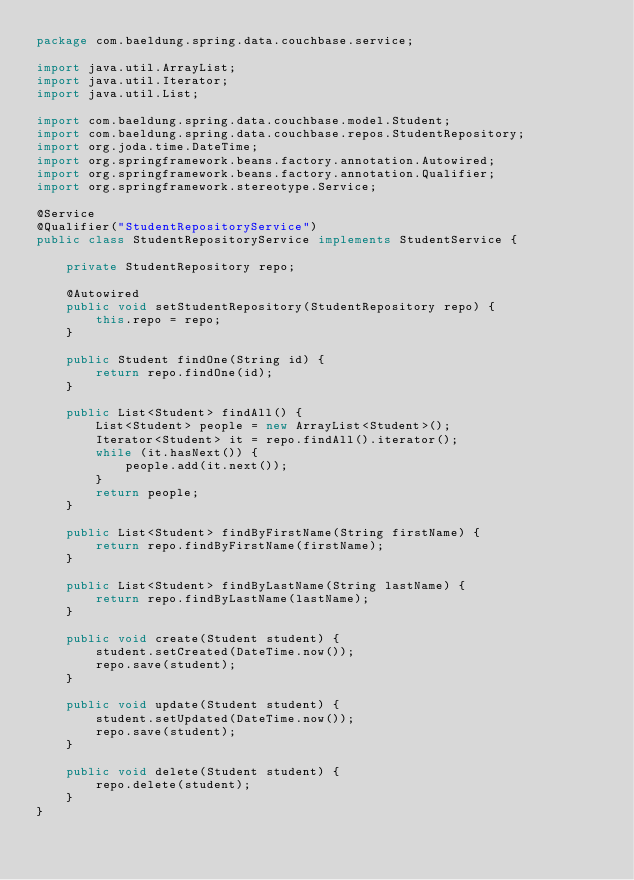<code> <loc_0><loc_0><loc_500><loc_500><_Java_>package com.baeldung.spring.data.couchbase.service;

import java.util.ArrayList;
import java.util.Iterator;
import java.util.List;

import com.baeldung.spring.data.couchbase.model.Student;
import com.baeldung.spring.data.couchbase.repos.StudentRepository;
import org.joda.time.DateTime;
import org.springframework.beans.factory.annotation.Autowired;
import org.springframework.beans.factory.annotation.Qualifier;
import org.springframework.stereotype.Service;

@Service
@Qualifier("StudentRepositoryService")
public class StudentRepositoryService implements StudentService {

    private StudentRepository repo;

    @Autowired
    public void setStudentRepository(StudentRepository repo) {
        this.repo = repo;
    }

    public Student findOne(String id) {
        return repo.findOne(id);
    }

    public List<Student> findAll() {
        List<Student> people = new ArrayList<Student>();
        Iterator<Student> it = repo.findAll().iterator();
        while (it.hasNext()) {
            people.add(it.next());
        }
        return people;
    }

    public List<Student> findByFirstName(String firstName) {
        return repo.findByFirstName(firstName);
    }

    public List<Student> findByLastName(String lastName) {
        return repo.findByLastName(lastName);
    }

    public void create(Student student) {
        student.setCreated(DateTime.now());
        repo.save(student);
    }

    public void update(Student student) {
        student.setUpdated(DateTime.now());
        repo.save(student);
    }

    public void delete(Student student) {
        repo.delete(student);
    }
}
</code> 